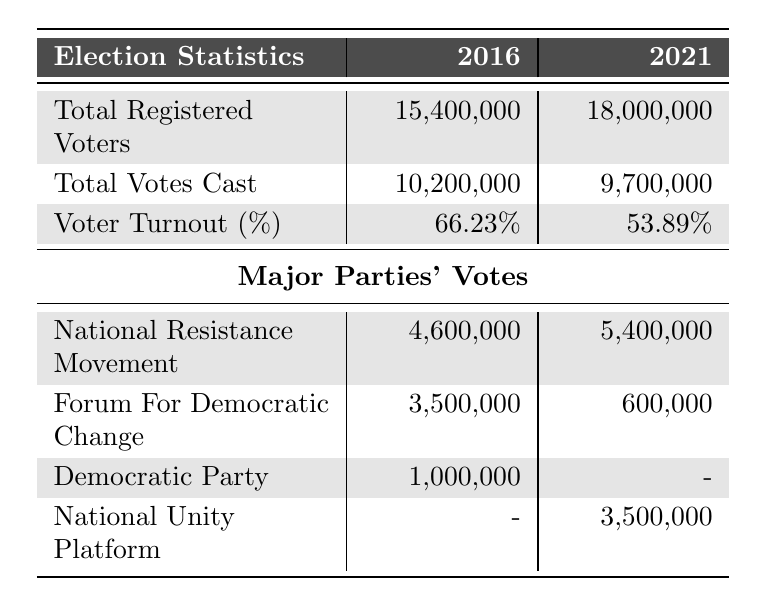What was the voter turnout percentage in 2016? The table shows that the voter turnout percentage for 2016 is listed directly under the "Voter Turnout (%)" row. It indicates a percentage of 66.23%.
Answer: 66.23% What was the total number of votes cast in 2021? Looking at the "Total Votes Cast" row for 2021, it shows that the total number of votes cast is 9,700,000.
Answer: 9,700,000 Which major party received the most votes in 2021? The votes for major parties in 2021 are listed, and the National Resistance Movement received 5,400,000 votes, which is the highest among the mentioned parties.
Answer: National Resistance Movement What is the difference in total registered voters between 2016 and 2021? Subtract the total registered voters in 2016 (15,400,000) from those in 2021 (18,000,000). The difference is 18,000,000 - 15,400,000 = 2,600,000.
Answer: 2,600,000 What was the voter turnout percentage decrease from 2016 to 2021? To find the decrease in voter turnout percentage, subtract the 2021 percentage (53.89%) from the 2016 percentage (66.23%). The calculation is 66.23% - 53.89% = 12.34%.
Answer: 12.34% Did the Forum for Democratic Change receive more votes in 2016 or 2021? The votes for the Forum for Democratic Change are 3,500,000 in 2016 and 600,000 in 2021. Comparing these two values shows that they received more votes in 2016.
Answer: Yes What is the total number of registered voters for both years combined? To find the total number of registered voters for both years, add the 2016 total (15,400,000) to the 2021 total (18,000,000). The sum is 15,400,000 + 18,000,000 = 33,400,000.
Answer: 33,400,000 What percentage of the total votes cast in 2021 did the National Unity Platform receive? First, the National Unity Platform received 3,500,000 votes in 2021. To calculate the percentage, divide 3,500,000 by the total votes cast (9,700,000) and multiply by 100. The calculation is (3,500,000 / 9,700,000) * 100 = 36.08%.
Answer: 36.08% What was the total number of votes cast for the Democratic Party across both years? The Democratic Party received 1,000,000 votes in 2016 and no votes recorded in 2021. Adding these gives 1,000,000 + 0 = 1,000,000.
Answer: 1,000,000 Was there an increase or decrease in the total votes cast from 2016 to 2021? Comparing the total votes cast, 10,200,000 in 2016 and 9,700,000 in 2021, shows a decrease. The calculation is 9,700,000 - 10,200,000 = -500,000.
Answer: Decrease How many more votes did the National Resistance Movement receive in 2021 compared to 2016? The National Resistance Movement received 5,400,000 votes in 2021 and 4,600,000 in 2016. Subtracting these gives 5,400,000 - 4,600,000 = 800,000 more votes in 2021.
Answer: 800,000 